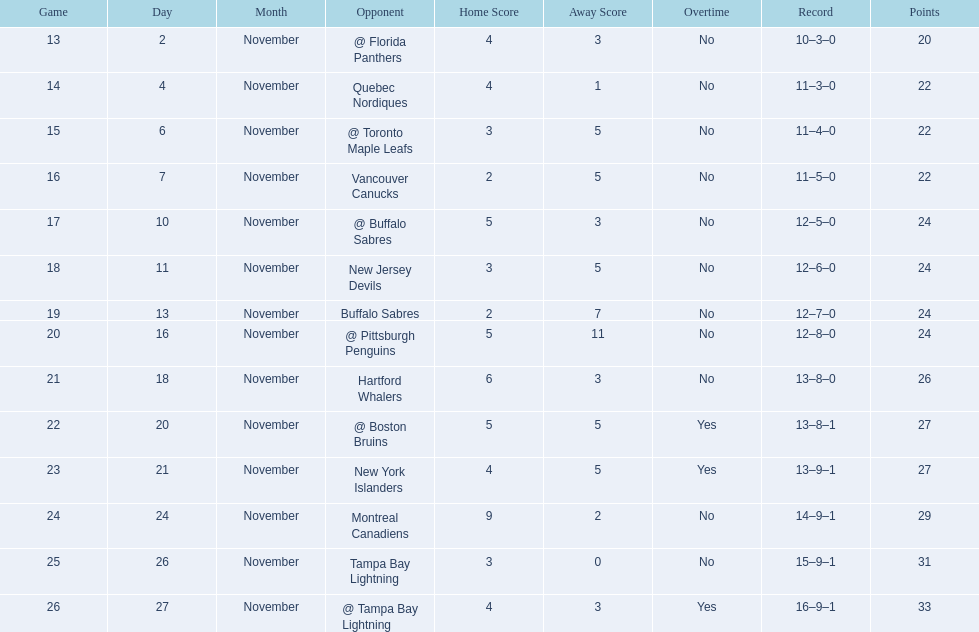What was the total penalty minutes that dave brown had on the 1993-1994 flyers? 137. 